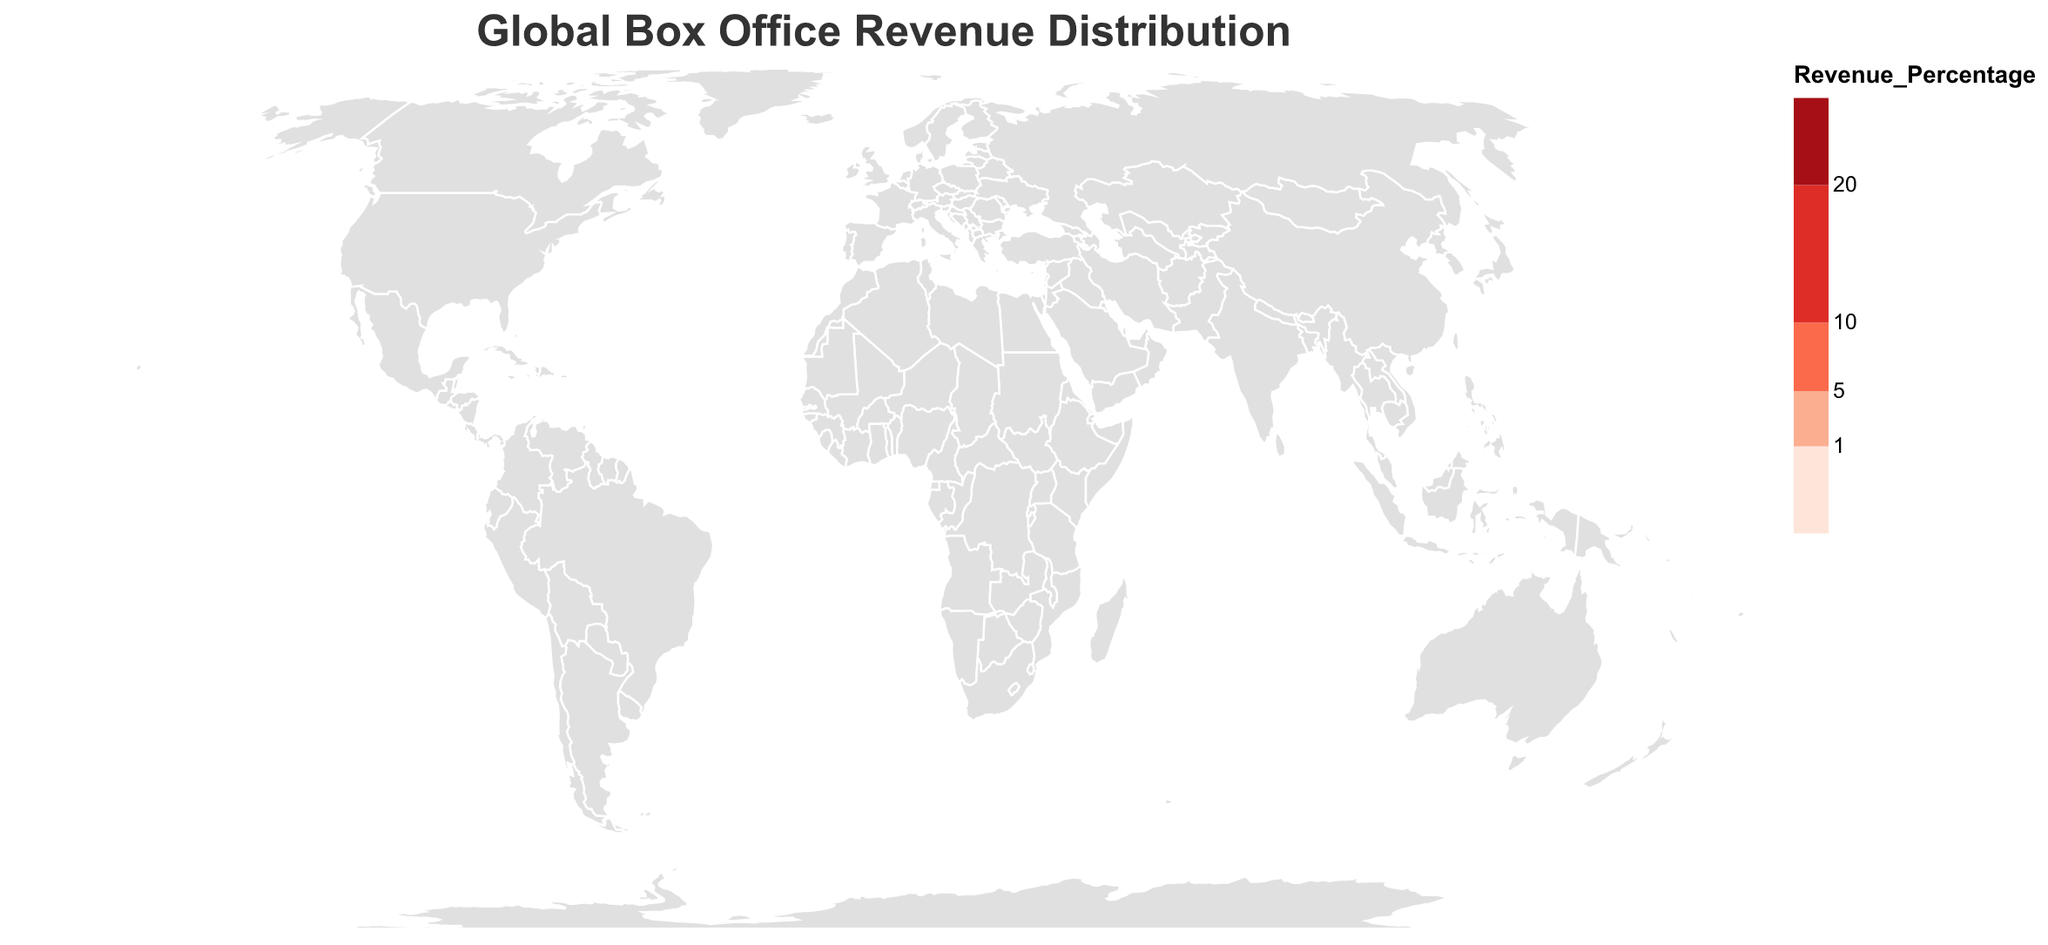Which country contributes the highest percentage of global box office revenue? By looking at the figure, the United States has the highest percentage of global box office revenue, as indicated by the highest color intensity and value
Answer: United States (35.2%) Which country has a box office revenue percentage closest to 10%? From the data, China and the United Kingdom are the closest, with China being 18.7% and the United Kingdom 7.3%. The United Kingdom is closer to 10%
Answer: United Kingdom (7.3%) What's the total box office revenue percentage for the top 5 contributing countries? The top 5 countries are the United States, China, United Kingdom, Japan, and South Korea. Their percentages are 35.2, 18.7, 7.3, 5.9, and 4.2, respectively. Summing these values gives 35.2 + 18.7 + 7.3 + 5.9 + 4.2 = 71.3
Answer: 71.3% How does South Korea's box office revenue compare to that of Germany? South Korea's revenue percentage is 4.2%, while Germany's is 3.5%. By comparison, South Korea has a higher box office revenue percentage than Germany
Answer: South Korea (4.2%) > Germany (3.5%) Which countries contribute less than 1% but more than 0.5% to global box office revenue? From the data, the countries falling in this range are the Netherlands (0.9%), Indonesia (0.8%), Taiwan (0.7%), and United Arab Emirates (0.6%)
Answer: Netherlands, Indonesia, Taiwan, United Arab Emirates What's the combined revenue percentage for all countries contributing less than 2%? The countries contributing less than 2% are Italy, Spain, Canada, Netherlands, Indonesia, Taiwan, United Arab Emirates, Argentina, Sweden, and Poland. Summing their percentages: 1.8 + 1.6 + 1.5 + 0.9 + 0.8 + 0.7 + 0.6 + 0.5 + 0.4 + 0.4 = 9.2
Answer: 9.2% Which country in Europe has the highest percentage of global box office revenue? From the data, the European countries listed are the United Kingdom, France, Germany, Italy, Spain, Netherlands, Sweden, and Poland. Among these, the United Kingdom has the highest percentage at 7.3%
Answer: United Kingdom How does Mexico compare to Brazil in terms of box office revenue contribution? Mexico contributes 2.4% while Brazil contributes 2.2% to the global box office. This shows that Mexico contributes a slightly higher percentage than Brazil
Answer: Mexico (2.4%) > Brazil (2.2%) What color represents the highest revenue percentage on the map? The highest revenue percentage (United States with 35.2%) is represented by the darkest red color on the map
Answer: Darkest red What percentage of global box office revenue is contributed by Asian countries listed? The Asian countries listed are China, Japan, South Korea, India, Indonesia, and Taiwan. Their percentages are 18.7, 5.9, 4.2, 2.1, 0.8, and 0.7 respectively. The sum is 18.7 + 5.9 + 4.2 + 2.1 + 0.8 + 0.7 = 32.4
Answer: 32.4% 